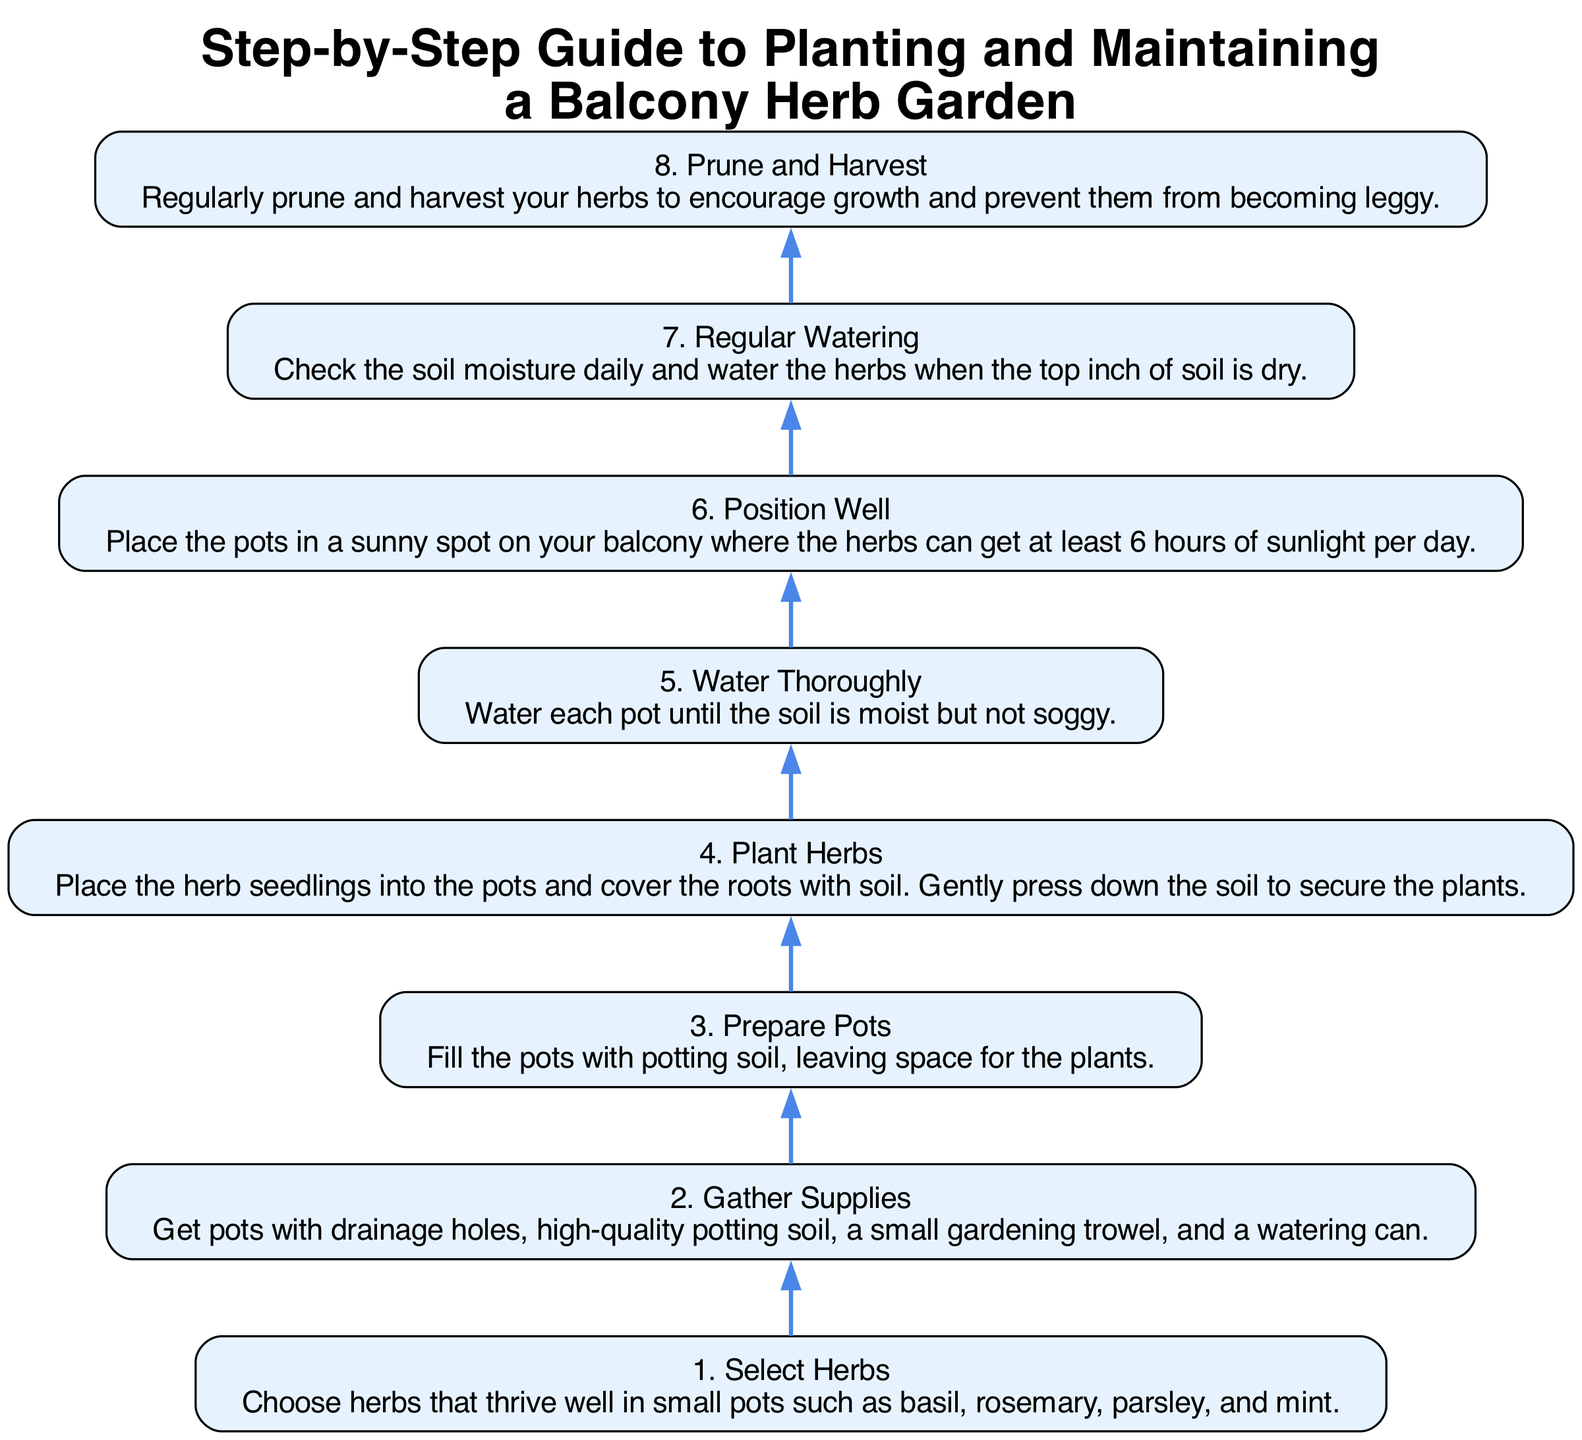What is the first step in planting a balcony herb garden? The diagram indicates that the first step is selecting herbs. This is clearly stated as "Select Herbs" in the first node.
Answer: Select Herbs How many total steps are there in the guide? By counting the nodes in the diagram, there are eight steps listed sequentially from the first to the last.
Answer: 8 What should you check daily after planting the herbs? The diagram prompts you to check the soil moisture daily after planting the herbs, as stated in the step for regular watering.
Answer: Soil moisture What is the last step mentioned in the diagram? The final node in the flow chart indicates that the last step is to prune and harvest the herbs. This information is found at the top of the diagram.
Answer: Prune and harvest Which step comes after watering thoroughly? Following the step of watering thoroughly, the next step according to the flow is to position the pots well. To find this, you trace the arrows between the nodes.
Answer: Position well What is needed to prepare the pots? The diagram specifies that filling the pots with potting soil and leaving space for plants is required to prepare the pots, as described in the corresponding node.
Answer: Potting soil If you do not prune your herbs, what might happen? The diagram suggests that not pruning can lead to the herbs becoming leggy; this is a reasoning step based on the connection between pruning and growth encouragement.
Answer: Leggy How many hours of sunlight do the herbs need? The diagram specifies that the herbs must receive at least 6 hours of sunlight per day as stated in the position well step.
Answer: 6 hours 